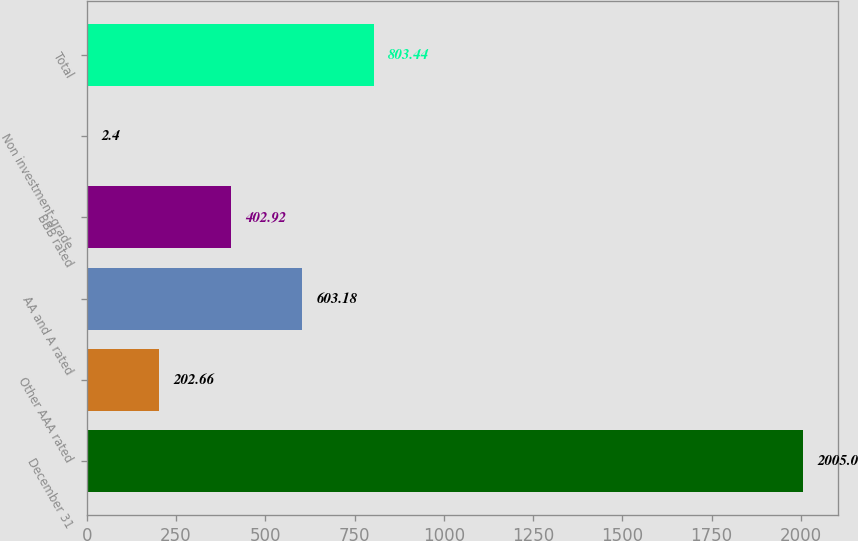Convert chart. <chart><loc_0><loc_0><loc_500><loc_500><bar_chart><fcel>December 31<fcel>Other AAA rated<fcel>AA and A rated<fcel>BBB rated<fcel>Non investment-grade<fcel>Total<nl><fcel>2005<fcel>202.66<fcel>603.18<fcel>402.92<fcel>2.4<fcel>803.44<nl></chart> 